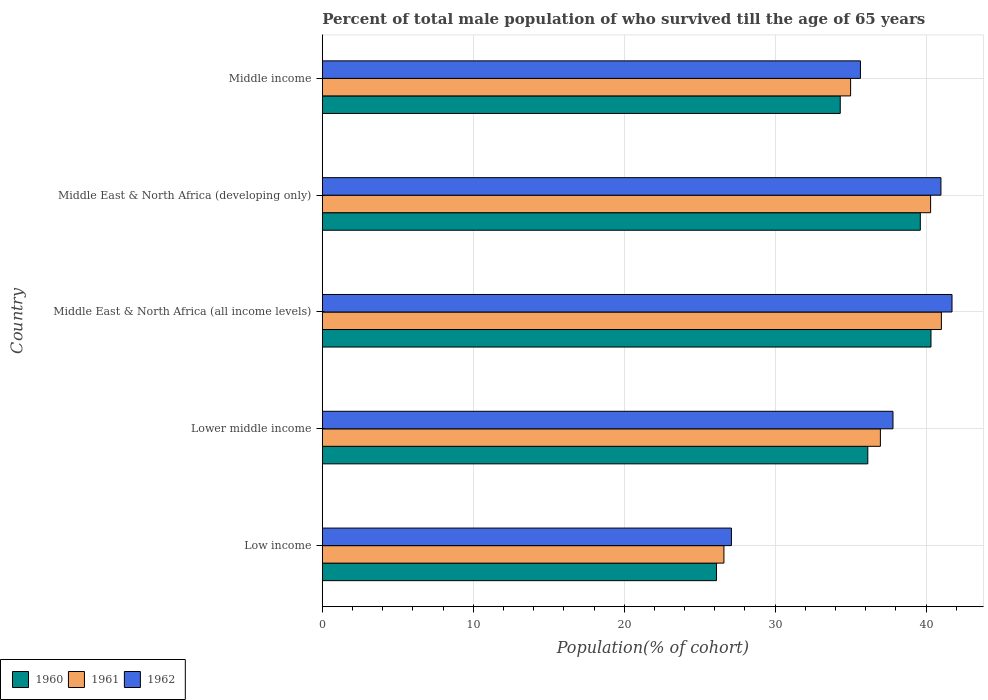How many different coloured bars are there?
Provide a short and direct response. 3. How many bars are there on the 5th tick from the top?
Give a very brief answer. 3. In how many cases, is the number of bars for a given country not equal to the number of legend labels?
Provide a succinct answer. 0. What is the percentage of total male population who survived till the age of 65 years in 1960 in Lower middle income?
Offer a terse response. 36.14. Across all countries, what is the maximum percentage of total male population who survived till the age of 65 years in 1962?
Offer a terse response. 41.72. Across all countries, what is the minimum percentage of total male population who survived till the age of 65 years in 1962?
Keep it short and to the point. 27.1. In which country was the percentage of total male population who survived till the age of 65 years in 1961 maximum?
Make the answer very short. Middle East & North Africa (all income levels). In which country was the percentage of total male population who survived till the age of 65 years in 1960 minimum?
Your answer should be compact. Low income. What is the total percentage of total male population who survived till the age of 65 years in 1961 in the graph?
Provide a short and direct response. 179.89. What is the difference between the percentage of total male population who survived till the age of 65 years in 1960 in Middle East & North Africa (all income levels) and that in Middle income?
Provide a succinct answer. 6.01. What is the difference between the percentage of total male population who survived till the age of 65 years in 1960 in Middle income and the percentage of total male population who survived till the age of 65 years in 1961 in Middle East & North Africa (all income levels)?
Offer a very short reply. -6.7. What is the average percentage of total male population who survived till the age of 65 years in 1962 per country?
Your response must be concise. 36.65. What is the difference between the percentage of total male population who survived till the age of 65 years in 1961 and percentage of total male population who survived till the age of 65 years in 1962 in Lower middle income?
Keep it short and to the point. -0.83. In how many countries, is the percentage of total male population who survived till the age of 65 years in 1960 greater than 10 %?
Your response must be concise. 5. What is the ratio of the percentage of total male population who survived till the age of 65 years in 1960 in Lower middle income to that in Middle East & North Africa (all income levels)?
Offer a terse response. 0.9. Is the percentage of total male population who survived till the age of 65 years in 1962 in Lower middle income less than that in Middle East & North Africa (all income levels)?
Offer a terse response. Yes. What is the difference between the highest and the second highest percentage of total male population who survived till the age of 65 years in 1962?
Make the answer very short. 0.73. What is the difference between the highest and the lowest percentage of total male population who survived till the age of 65 years in 1961?
Provide a short and direct response. 14.41. In how many countries, is the percentage of total male population who survived till the age of 65 years in 1962 greater than the average percentage of total male population who survived till the age of 65 years in 1962 taken over all countries?
Offer a very short reply. 3. What does the 2nd bar from the top in Middle East & North Africa (all income levels) represents?
Your response must be concise. 1961. Are all the bars in the graph horizontal?
Provide a succinct answer. Yes. What is the difference between two consecutive major ticks on the X-axis?
Keep it short and to the point. 10. Are the values on the major ticks of X-axis written in scientific E-notation?
Make the answer very short. No. Does the graph contain any zero values?
Make the answer very short. No. Does the graph contain grids?
Keep it short and to the point. Yes. How are the legend labels stacked?
Provide a short and direct response. Horizontal. What is the title of the graph?
Your response must be concise. Percent of total male population of who survived till the age of 65 years. What is the label or title of the X-axis?
Make the answer very short. Population(% of cohort). What is the Population(% of cohort) in 1960 in Low income?
Provide a succinct answer. 26.12. What is the Population(% of cohort) of 1961 in Low income?
Provide a short and direct response. 26.61. What is the Population(% of cohort) of 1962 in Low income?
Make the answer very short. 27.1. What is the Population(% of cohort) in 1960 in Lower middle income?
Offer a very short reply. 36.14. What is the Population(% of cohort) in 1961 in Lower middle income?
Provide a short and direct response. 36.97. What is the Population(% of cohort) of 1962 in Lower middle income?
Ensure brevity in your answer.  37.81. What is the Population(% of cohort) of 1960 in Middle East & North Africa (all income levels)?
Provide a short and direct response. 40.32. What is the Population(% of cohort) of 1961 in Middle East & North Africa (all income levels)?
Ensure brevity in your answer.  41.01. What is the Population(% of cohort) of 1962 in Middle East & North Africa (all income levels)?
Offer a very short reply. 41.72. What is the Population(% of cohort) of 1960 in Middle East & North Africa (developing only)?
Keep it short and to the point. 39.62. What is the Population(% of cohort) in 1961 in Middle East & North Africa (developing only)?
Offer a terse response. 40.3. What is the Population(% of cohort) of 1962 in Middle East & North Africa (developing only)?
Make the answer very short. 40.98. What is the Population(% of cohort) in 1960 in Middle income?
Your answer should be compact. 34.31. What is the Population(% of cohort) of 1961 in Middle income?
Your answer should be very brief. 35. What is the Population(% of cohort) of 1962 in Middle income?
Keep it short and to the point. 35.65. Across all countries, what is the maximum Population(% of cohort) of 1960?
Offer a terse response. 40.32. Across all countries, what is the maximum Population(% of cohort) in 1961?
Your answer should be compact. 41.01. Across all countries, what is the maximum Population(% of cohort) of 1962?
Offer a very short reply. 41.72. Across all countries, what is the minimum Population(% of cohort) of 1960?
Provide a short and direct response. 26.12. Across all countries, what is the minimum Population(% of cohort) of 1961?
Offer a very short reply. 26.61. Across all countries, what is the minimum Population(% of cohort) in 1962?
Offer a terse response. 27.1. What is the total Population(% of cohort) in 1960 in the graph?
Make the answer very short. 176.51. What is the total Population(% of cohort) of 1961 in the graph?
Provide a succinct answer. 179.89. What is the total Population(% of cohort) in 1962 in the graph?
Offer a terse response. 183.26. What is the difference between the Population(% of cohort) in 1960 in Low income and that in Lower middle income?
Make the answer very short. -10.02. What is the difference between the Population(% of cohort) of 1961 in Low income and that in Lower middle income?
Your response must be concise. -10.37. What is the difference between the Population(% of cohort) of 1962 in Low income and that in Lower middle income?
Keep it short and to the point. -10.7. What is the difference between the Population(% of cohort) of 1960 in Low income and that in Middle East & North Africa (all income levels)?
Make the answer very short. -14.21. What is the difference between the Population(% of cohort) in 1961 in Low income and that in Middle East & North Africa (all income levels)?
Your response must be concise. -14.41. What is the difference between the Population(% of cohort) in 1962 in Low income and that in Middle East & North Africa (all income levels)?
Keep it short and to the point. -14.61. What is the difference between the Population(% of cohort) of 1960 in Low income and that in Middle East & North Africa (developing only)?
Make the answer very short. -13.5. What is the difference between the Population(% of cohort) of 1961 in Low income and that in Middle East & North Africa (developing only)?
Provide a short and direct response. -13.69. What is the difference between the Population(% of cohort) of 1962 in Low income and that in Middle East & North Africa (developing only)?
Your response must be concise. -13.88. What is the difference between the Population(% of cohort) of 1960 in Low income and that in Middle income?
Your response must be concise. -8.2. What is the difference between the Population(% of cohort) in 1961 in Low income and that in Middle income?
Keep it short and to the point. -8.39. What is the difference between the Population(% of cohort) in 1962 in Low income and that in Middle income?
Make the answer very short. -8.55. What is the difference between the Population(% of cohort) in 1960 in Lower middle income and that in Middle East & North Africa (all income levels)?
Offer a terse response. -4.19. What is the difference between the Population(% of cohort) in 1961 in Lower middle income and that in Middle East & North Africa (all income levels)?
Your answer should be very brief. -4.04. What is the difference between the Population(% of cohort) in 1962 in Lower middle income and that in Middle East & North Africa (all income levels)?
Offer a terse response. -3.91. What is the difference between the Population(% of cohort) in 1960 in Lower middle income and that in Middle East & North Africa (developing only)?
Keep it short and to the point. -3.48. What is the difference between the Population(% of cohort) in 1961 in Lower middle income and that in Middle East & North Africa (developing only)?
Make the answer very short. -3.33. What is the difference between the Population(% of cohort) of 1962 in Lower middle income and that in Middle East & North Africa (developing only)?
Your answer should be very brief. -3.18. What is the difference between the Population(% of cohort) in 1960 in Lower middle income and that in Middle income?
Provide a succinct answer. 1.83. What is the difference between the Population(% of cohort) of 1961 in Lower middle income and that in Middle income?
Offer a very short reply. 1.97. What is the difference between the Population(% of cohort) of 1962 in Lower middle income and that in Middle income?
Give a very brief answer. 2.16. What is the difference between the Population(% of cohort) of 1960 in Middle East & North Africa (all income levels) and that in Middle East & North Africa (developing only)?
Provide a succinct answer. 0.71. What is the difference between the Population(% of cohort) of 1961 in Middle East & North Africa (all income levels) and that in Middle East & North Africa (developing only)?
Offer a terse response. 0.71. What is the difference between the Population(% of cohort) in 1962 in Middle East & North Africa (all income levels) and that in Middle East & North Africa (developing only)?
Provide a short and direct response. 0.73. What is the difference between the Population(% of cohort) of 1960 in Middle East & North Africa (all income levels) and that in Middle income?
Give a very brief answer. 6.01. What is the difference between the Population(% of cohort) in 1961 in Middle East & North Africa (all income levels) and that in Middle income?
Your answer should be very brief. 6.01. What is the difference between the Population(% of cohort) in 1962 in Middle East & North Africa (all income levels) and that in Middle income?
Provide a short and direct response. 6.07. What is the difference between the Population(% of cohort) in 1960 in Middle East & North Africa (developing only) and that in Middle income?
Your answer should be very brief. 5.3. What is the difference between the Population(% of cohort) in 1961 in Middle East & North Africa (developing only) and that in Middle income?
Offer a very short reply. 5.3. What is the difference between the Population(% of cohort) in 1962 in Middle East & North Africa (developing only) and that in Middle income?
Provide a short and direct response. 5.33. What is the difference between the Population(% of cohort) in 1960 in Low income and the Population(% of cohort) in 1961 in Lower middle income?
Your answer should be very brief. -10.86. What is the difference between the Population(% of cohort) in 1960 in Low income and the Population(% of cohort) in 1962 in Lower middle income?
Your answer should be very brief. -11.69. What is the difference between the Population(% of cohort) of 1961 in Low income and the Population(% of cohort) of 1962 in Lower middle income?
Give a very brief answer. -11.2. What is the difference between the Population(% of cohort) of 1960 in Low income and the Population(% of cohort) of 1961 in Middle East & North Africa (all income levels)?
Your response must be concise. -14.9. What is the difference between the Population(% of cohort) in 1960 in Low income and the Population(% of cohort) in 1962 in Middle East & North Africa (all income levels)?
Make the answer very short. -15.6. What is the difference between the Population(% of cohort) of 1961 in Low income and the Population(% of cohort) of 1962 in Middle East & North Africa (all income levels)?
Ensure brevity in your answer.  -15.11. What is the difference between the Population(% of cohort) in 1960 in Low income and the Population(% of cohort) in 1961 in Middle East & North Africa (developing only)?
Make the answer very short. -14.18. What is the difference between the Population(% of cohort) in 1960 in Low income and the Population(% of cohort) in 1962 in Middle East & North Africa (developing only)?
Keep it short and to the point. -14.87. What is the difference between the Population(% of cohort) of 1961 in Low income and the Population(% of cohort) of 1962 in Middle East & North Africa (developing only)?
Your answer should be compact. -14.38. What is the difference between the Population(% of cohort) of 1960 in Low income and the Population(% of cohort) of 1961 in Middle income?
Offer a very short reply. -8.88. What is the difference between the Population(% of cohort) of 1960 in Low income and the Population(% of cohort) of 1962 in Middle income?
Your answer should be very brief. -9.54. What is the difference between the Population(% of cohort) in 1961 in Low income and the Population(% of cohort) in 1962 in Middle income?
Ensure brevity in your answer.  -9.04. What is the difference between the Population(% of cohort) in 1960 in Lower middle income and the Population(% of cohort) in 1961 in Middle East & North Africa (all income levels)?
Make the answer very short. -4.88. What is the difference between the Population(% of cohort) in 1960 in Lower middle income and the Population(% of cohort) in 1962 in Middle East & North Africa (all income levels)?
Give a very brief answer. -5.58. What is the difference between the Population(% of cohort) in 1961 in Lower middle income and the Population(% of cohort) in 1962 in Middle East & North Africa (all income levels)?
Your answer should be very brief. -4.74. What is the difference between the Population(% of cohort) in 1960 in Lower middle income and the Population(% of cohort) in 1961 in Middle East & North Africa (developing only)?
Give a very brief answer. -4.16. What is the difference between the Population(% of cohort) in 1960 in Lower middle income and the Population(% of cohort) in 1962 in Middle East & North Africa (developing only)?
Offer a terse response. -4.84. What is the difference between the Population(% of cohort) in 1961 in Lower middle income and the Population(% of cohort) in 1962 in Middle East & North Africa (developing only)?
Your answer should be very brief. -4.01. What is the difference between the Population(% of cohort) of 1960 in Lower middle income and the Population(% of cohort) of 1961 in Middle income?
Your response must be concise. 1.14. What is the difference between the Population(% of cohort) of 1960 in Lower middle income and the Population(% of cohort) of 1962 in Middle income?
Your answer should be very brief. 0.49. What is the difference between the Population(% of cohort) in 1961 in Lower middle income and the Population(% of cohort) in 1962 in Middle income?
Your response must be concise. 1.32. What is the difference between the Population(% of cohort) in 1960 in Middle East & North Africa (all income levels) and the Population(% of cohort) in 1961 in Middle East & North Africa (developing only)?
Your answer should be very brief. 0.02. What is the difference between the Population(% of cohort) of 1960 in Middle East & North Africa (all income levels) and the Population(% of cohort) of 1962 in Middle East & North Africa (developing only)?
Offer a very short reply. -0.66. What is the difference between the Population(% of cohort) of 1961 in Middle East & North Africa (all income levels) and the Population(% of cohort) of 1962 in Middle East & North Africa (developing only)?
Your response must be concise. 0.03. What is the difference between the Population(% of cohort) of 1960 in Middle East & North Africa (all income levels) and the Population(% of cohort) of 1961 in Middle income?
Ensure brevity in your answer.  5.32. What is the difference between the Population(% of cohort) of 1960 in Middle East & North Africa (all income levels) and the Population(% of cohort) of 1962 in Middle income?
Your response must be concise. 4.67. What is the difference between the Population(% of cohort) of 1961 in Middle East & North Africa (all income levels) and the Population(% of cohort) of 1962 in Middle income?
Give a very brief answer. 5.36. What is the difference between the Population(% of cohort) of 1960 in Middle East & North Africa (developing only) and the Population(% of cohort) of 1961 in Middle income?
Offer a terse response. 4.62. What is the difference between the Population(% of cohort) in 1960 in Middle East & North Africa (developing only) and the Population(% of cohort) in 1962 in Middle income?
Give a very brief answer. 3.97. What is the difference between the Population(% of cohort) of 1961 in Middle East & North Africa (developing only) and the Population(% of cohort) of 1962 in Middle income?
Your answer should be very brief. 4.65. What is the average Population(% of cohort) of 1960 per country?
Your response must be concise. 35.3. What is the average Population(% of cohort) in 1961 per country?
Offer a terse response. 35.98. What is the average Population(% of cohort) in 1962 per country?
Provide a succinct answer. 36.65. What is the difference between the Population(% of cohort) in 1960 and Population(% of cohort) in 1961 in Low income?
Offer a very short reply. -0.49. What is the difference between the Population(% of cohort) of 1960 and Population(% of cohort) of 1962 in Low income?
Your answer should be compact. -0.99. What is the difference between the Population(% of cohort) in 1961 and Population(% of cohort) in 1962 in Low income?
Your answer should be compact. -0.5. What is the difference between the Population(% of cohort) of 1960 and Population(% of cohort) of 1961 in Lower middle income?
Offer a very short reply. -0.83. What is the difference between the Population(% of cohort) in 1960 and Population(% of cohort) in 1962 in Lower middle income?
Make the answer very short. -1.67. What is the difference between the Population(% of cohort) in 1961 and Population(% of cohort) in 1962 in Lower middle income?
Your response must be concise. -0.83. What is the difference between the Population(% of cohort) in 1960 and Population(% of cohort) in 1961 in Middle East & North Africa (all income levels)?
Keep it short and to the point. -0.69. What is the difference between the Population(% of cohort) in 1960 and Population(% of cohort) in 1962 in Middle East & North Africa (all income levels)?
Your answer should be very brief. -1.39. What is the difference between the Population(% of cohort) in 1961 and Population(% of cohort) in 1962 in Middle East & North Africa (all income levels)?
Give a very brief answer. -0.7. What is the difference between the Population(% of cohort) of 1960 and Population(% of cohort) of 1961 in Middle East & North Africa (developing only)?
Ensure brevity in your answer.  -0.68. What is the difference between the Population(% of cohort) of 1960 and Population(% of cohort) of 1962 in Middle East & North Africa (developing only)?
Give a very brief answer. -1.37. What is the difference between the Population(% of cohort) of 1961 and Population(% of cohort) of 1962 in Middle East & North Africa (developing only)?
Keep it short and to the point. -0.68. What is the difference between the Population(% of cohort) in 1960 and Population(% of cohort) in 1961 in Middle income?
Provide a succinct answer. -0.69. What is the difference between the Population(% of cohort) in 1960 and Population(% of cohort) in 1962 in Middle income?
Give a very brief answer. -1.34. What is the difference between the Population(% of cohort) in 1961 and Population(% of cohort) in 1962 in Middle income?
Your answer should be compact. -0.65. What is the ratio of the Population(% of cohort) in 1960 in Low income to that in Lower middle income?
Your response must be concise. 0.72. What is the ratio of the Population(% of cohort) in 1961 in Low income to that in Lower middle income?
Your answer should be compact. 0.72. What is the ratio of the Population(% of cohort) of 1962 in Low income to that in Lower middle income?
Your response must be concise. 0.72. What is the ratio of the Population(% of cohort) in 1960 in Low income to that in Middle East & North Africa (all income levels)?
Your answer should be very brief. 0.65. What is the ratio of the Population(% of cohort) of 1961 in Low income to that in Middle East & North Africa (all income levels)?
Provide a succinct answer. 0.65. What is the ratio of the Population(% of cohort) of 1962 in Low income to that in Middle East & North Africa (all income levels)?
Your answer should be very brief. 0.65. What is the ratio of the Population(% of cohort) of 1960 in Low income to that in Middle East & North Africa (developing only)?
Give a very brief answer. 0.66. What is the ratio of the Population(% of cohort) of 1961 in Low income to that in Middle East & North Africa (developing only)?
Your answer should be compact. 0.66. What is the ratio of the Population(% of cohort) in 1962 in Low income to that in Middle East & North Africa (developing only)?
Your response must be concise. 0.66. What is the ratio of the Population(% of cohort) in 1960 in Low income to that in Middle income?
Keep it short and to the point. 0.76. What is the ratio of the Population(% of cohort) of 1961 in Low income to that in Middle income?
Your answer should be very brief. 0.76. What is the ratio of the Population(% of cohort) in 1962 in Low income to that in Middle income?
Offer a terse response. 0.76. What is the ratio of the Population(% of cohort) in 1960 in Lower middle income to that in Middle East & North Africa (all income levels)?
Your answer should be very brief. 0.9. What is the ratio of the Population(% of cohort) in 1961 in Lower middle income to that in Middle East & North Africa (all income levels)?
Your answer should be compact. 0.9. What is the ratio of the Population(% of cohort) of 1962 in Lower middle income to that in Middle East & North Africa (all income levels)?
Ensure brevity in your answer.  0.91. What is the ratio of the Population(% of cohort) of 1960 in Lower middle income to that in Middle East & North Africa (developing only)?
Offer a very short reply. 0.91. What is the ratio of the Population(% of cohort) in 1961 in Lower middle income to that in Middle East & North Africa (developing only)?
Your answer should be compact. 0.92. What is the ratio of the Population(% of cohort) of 1962 in Lower middle income to that in Middle East & North Africa (developing only)?
Your answer should be very brief. 0.92. What is the ratio of the Population(% of cohort) of 1960 in Lower middle income to that in Middle income?
Make the answer very short. 1.05. What is the ratio of the Population(% of cohort) of 1961 in Lower middle income to that in Middle income?
Your answer should be very brief. 1.06. What is the ratio of the Population(% of cohort) of 1962 in Lower middle income to that in Middle income?
Provide a short and direct response. 1.06. What is the ratio of the Population(% of cohort) in 1960 in Middle East & North Africa (all income levels) to that in Middle East & North Africa (developing only)?
Offer a terse response. 1.02. What is the ratio of the Population(% of cohort) of 1961 in Middle East & North Africa (all income levels) to that in Middle East & North Africa (developing only)?
Give a very brief answer. 1.02. What is the ratio of the Population(% of cohort) in 1962 in Middle East & North Africa (all income levels) to that in Middle East & North Africa (developing only)?
Your response must be concise. 1.02. What is the ratio of the Population(% of cohort) in 1960 in Middle East & North Africa (all income levels) to that in Middle income?
Keep it short and to the point. 1.18. What is the ratio of the Population(% of cohort) of 1961 in Middle East & North Africa (all income levels) to that in Middle income?
Offer a very short reply. 1.17. What is the ratio of the Population(% of cohort) in 1962 in Middle East & North Africa (all income levels) to that in Middle income?
Make the answer very short. 1.17. What is the ratio of the Population(% of cohort) in 1960 in Middle East & North Africa (developing only) to that in Middle income?
Provide a succinct answer. 1.15. What is the ratio of the Population(% of cohort) of 1961 in Middle East & North Africa (developing only) to that in Middle income?
Your answer should be very brief. 1.15. What is the ratio of the Population(% of cohort) of 1962 in Middle East & North Africa (developing only) to that in Middle income?
Provide a short and direct response. 1.15. What is the difference between the highest and the second highest Population(% of cohort) of 1960?
Your answer should be compact. 0.71. What is the difference between the highest and the second highest Population(% of cohort) in 1961?
Your answer should be very brief. 0.71. What is the difference between the highest and the second highest Population(% of cohort) in 1962?
Your answer should be compact. 0.73. What is the difference between the highest and the lowest Population(% of cohort) in 1960?
Your answer should be compact. 14.21. What is the difference between the highest and the lowest Population(% of cohort) of 1961?
Keep it short and to the point. 14.41. What is the difference between the highest and the lowest Population(% of cohort) of 1962?
Keep it short and to the point. 14.61. 